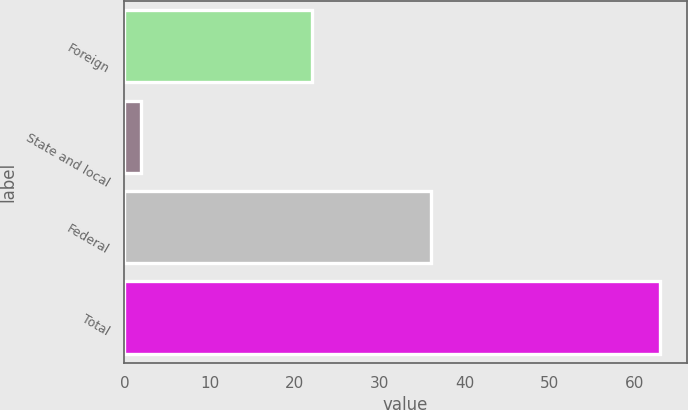Convert chart to OTSL. <chart><loc_0><loc_0><loc_500><loc_500><bar_chart><fcel>Foreign<fcel>State and local<fcel>Federal<fcel>Total<nl><fcel>22<fcel>2<fcel>36<fcel>63<nl></chart> 